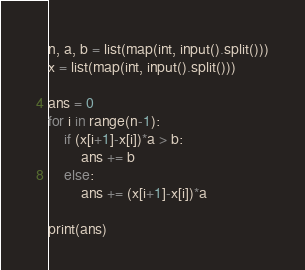<code> <loc_0><loc_0><loc_500><loc_500><_Python_>n, a, b = list(map(int, input().split()))
x = list(map(int, input().split()))

ans = 0
for i in range(n-1):
    if (x[i+1]-x[i])*a > b:
        ans += b
    else:
        ans += (x[i+1]-x[i])*a

print(ans)
</code> 